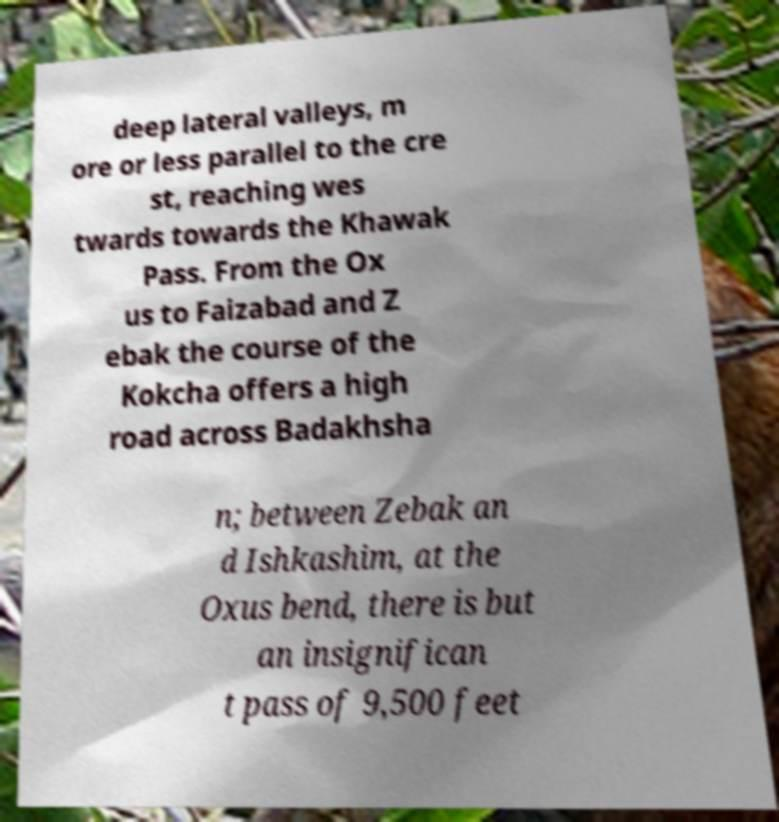Could you extract and type out the text from this image? deep lateral valleys, m ore or less parallel to the cre st, reaching wes twards towards the Khawak Pass. From the Ox us to Faizabad and Z ebak the course of the Kokcha offers a high road across Badakhsha n; between Zebak an d Ishkashim, at the Oxus bend, there is but an insignifican t pass of 9,500 feet 